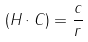<formula> <loc_0><loc_0><loc_500><loc_500>( H \cdot C ) = \frac { c } { r }</formula> 